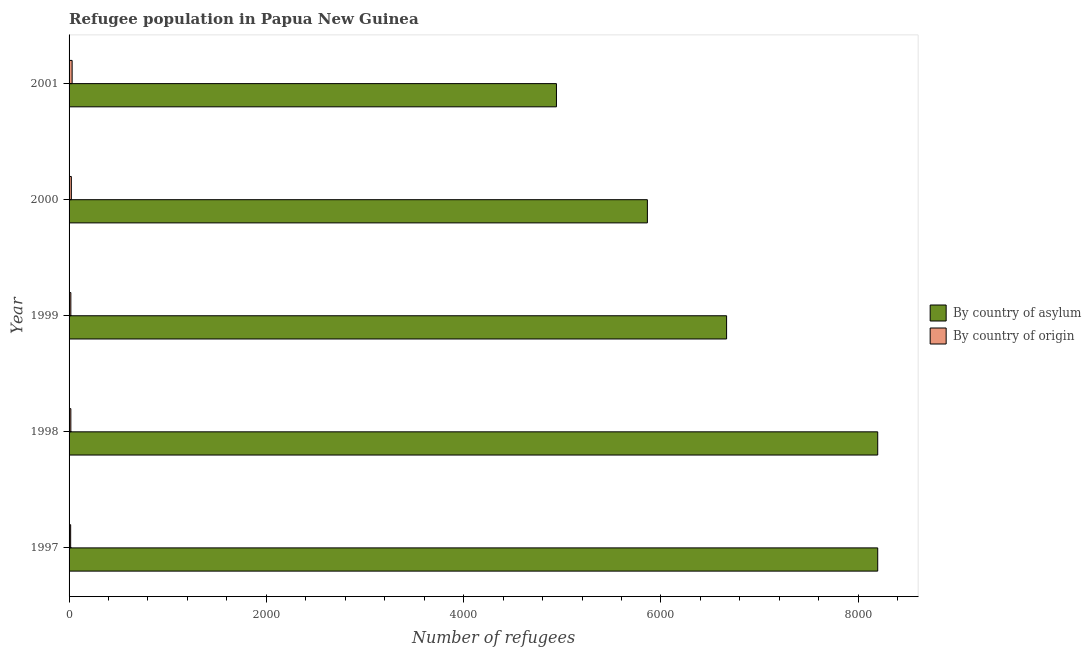How many different coloured bars are there?
Your answer should be compact. 2. How many groups of bars are there?
Your response must be concise. 5. How many bars are there on the 3rd tick from the top?
Make the answer very short. 2. How many bars are there on the 1st tick from the bottom?
Provide a succinct answer. 2. What is the label of the 4th group of bars from the top?
Your answer should be very brief. 1998. In how many cases, is the number of bars for a given year not equal to the number of legend labels?
Ensure brevity in your answer.  0. What is the number of refugees by country of origin in 1999?
Give a very brief answer. 18. Across all years, what is the maximum number of refugees by country of origin?
Ensure brevity in your answer.  31. Across all years, what is the minimum number of refugees by country of asylum?
Provide a succinct answer. 4941. What is the total number of refugees by country of origin in the graph?
Ensure brevity in your answer.  106. What is the difference between the number of refugees by country of asylum in 1997 and that in 2001?
Keep it short and to the point. 3257. What is the difference between the number of refugees by country of origin in 1998 and the number of refugees by country of asylum in 2001?
Offer a terse response. -4923. What is the average number of refugees by country of asylum per year?
Your answer should be very brief. 6773.2. In the year 2001, what is the difference between the number of refugees by country of origin and number of refugees by country of asylum?
Your response must be concise. -4910. What is the ratio of the number of refugees by country of origin in 1999 to that in 2001?
Offer a very short reply. 0.58. Is the number of refugees by country of asylum in 1999 less than that in 2000?
Offer a very short reply. No. Is the difference between the number of refugees by country of origin in 1999 and 2001 greater than the difference between the number of refugees by country of asylum in 1999 and 2001?
Your answer should be compact. No. What is the difference between the highest and the second highest number of refugees by country of asylum?
Make the answer very short. 0. What is the difference between the highest and the lowest number of refugees by country of origin?
Give a very brief answer. 15. What does the 1st bar from the top in 1998 represents?
Offer a very short reply. By country of origin. What does the 2nd bar from the bottom in 1997 represents?
Give a very brief answer. By country of origin. Are the values on the major ticks of X-axis written in scientific E-notation?
Offer a very short reply. No. Where does the legend appear in the graph?
Offer a very short reply. Center right. How are the legend labels stacked?
Provide a succinct answer. Vertical. What is the title of the graph?
Offer a very short reply. Refugee population in Papua New Guinea. What is the label or title of the X-axis?
Provide a short and direct response. Number of refugees. What is the Number of refugees of By country of asylum in 1997?
Make the answer very short. 8198. What is the Number of refugees of By country of asylum in 1998?
Provide a short and direct response. 8198. What is the Number of refugees of By country of asylum in 1999?
Offer a very short reply. 6666. What is the Number of refugees of By country of asylum in 2000?
Provide a short and direct response. 5863. What is the Number of refugees in By country of origin in 2000?
Your answer should be very brief. 23. What is the Number of refugees in By country of asylum in 2001?
Your response must be concise. 4941. Across all years, what is the maximum Number of refugees in By country of asylum?
Provide a short and direct response. 8198. Across all years, what is the minimum Number of refugees in By country of asylum?
Give a very brief answer. 4941. Across all years, what is the minimum Number of refugees of By country of origin?
Your answer should be very brief. 16. What is the total Number of refugees of By country of asylum in the graph?
Provide a succinct answer. 3.39e+04. What is the total Number of refugees of By country of origin in the graph?
Your response must be concise. 106. What is the difference between the Number of refugees of By country of origin in 1997 and that in 1998?
Keep it short and to the point. -2. What is the difference between the Number of refugees of By country of asylum in 1997 and that in 1999?
Offer a very short reply. 1532. What is the difference between the Number of refugees in By country of asylum in 1997 and that in 2000?
Provide a succinct answer. 2335. What is the difference between the Number of refugees of By country of origin in 1997 and that in 2000?
Your response must be concise. -7. What is the difference between the Number of refugees of By country of asylum in 1997 and that in 2001?
Make the answer very short. 3257. What is the difference between the Number of refugees of By country of asylum in 1998 and that in 1999?
Your answer should be very brief. 1532. What is the difference between the Number of refugees of By country of asylum in 1998 and that in 2000?
Give a very brief answer. 2335. What is the difference between the Number of refugees in By country of origin in 1998 and that in 2000?
Provide a short and direct response. -5. What is the difference between the Number of refugees of By country of asylum in 1998 and that in 2001?
Keep it short and to the point. 3257. What is the difference between the Number of refugees in By country of asylum in 1999 and that in 2000?
Your answer should be compact. 803. What is the difference between the Number of refugees of By country of origin in 1999 and that in 2000?
Provide a short and direct response. -5. What is the difference between the Number of refugees in By country of asylum in 1999 and that in 2001?
Provide a succinct answer. 1725. What is the difference between the Number of refugees of By country of origin in 1999 and that in 2001?
Ensure brevity in your answer.  -13. What is the difference between the Number of refugees of By country of asylum in 2000 and that in 2001?
Your answer should be very brief. 922. What is the difference between the Number of refugees in By country of asylum in 1997 and the Number of refugees in By country of origin in 1998?
Give a very brief answer. 8180. What is the difference between the Number of refugees in By country of asylum in 1997 and the Number of refugees in By country of origin in 1999?
Your answer should be very brief. 8180. What is the difference between the Number of refugees of By country of asylum in 1997 and the Number of refugees of By country of origin in 2000?
Offer a very short reply. 8175. What is the difference between the Number of refugees of By country of asylum in 1997 and the Number of refugees of By country of origin in 2001?
Your response must be concise. 8167. What is the difference between the Number of refugees in By country of asylum in 1998 and the Number of refugees in By country of origin in 1999?
Your answer should be compact. 8180. What is the difference between the Number of refugees of By country of asylum in 1998 and the Number of refugees of By country of origin in 2000?
Ensure brevity in your answer.  8175. What is the difference between the Number of refugees of By country of asylum in 1998 and the Number of refugees of By country of origin in 2001?
Give a very brief answer. 8167. What is the difference between the Number of refugees of By country of asylum in 1999 and the Number of refugees of By country of origin in 2000?
Keep it short and to the point. 6643. What is the difference between the Number of refugees in By country of asylum in 1999 and the Number of refugees in By country of origin in 2001?
Give a very brief answer. 6635. What is the difference between the Number of refugees in By country of asylum in 2000 and the Number of refugees in By country of origin in 2001?
Your response must be concise. 5832. What is the average Number of refugees in By country of asylum per year?
Offer a very short reply. 6773.2. What is the average Number of refugees of By country of origin per year?
Provide a short and direct response. 21.2. In the year 1997, what is the difference between the Number of refugees of By country of asylum and Number of refugees of By country of origin?
Make the answer very short. 8182. In the year 1998, what is the difference between the Number of refugees of By country of asylum and Number of refugees of By country of origin?
Keep it short and to the point. 8180. In the year 1999, what is the difference between the Number of refugees of By country of asylum and Number of refugees of By country of origin?
Ensure brevity in your answer.  6648. In the year 2000, what is the difference between the Number of refugees of By country of asylum and Number of refugees of By country of origin?
Offer a terse response. 5840. In the year 2001, what is the difference between the Number of refugees of By country of asylum and Number of refugees of By country of origin?
Give a very brief answer. 4910. What is the ratio of the Number of refugees of By country of asylum in 1997 to that in 1999?
Offer a terse response. 1.23. What is the ratio of the Number of refugees of By country of origin in 1997 to that in 1999?
Keep it short and to the point. 0.89. What is the ratio of the Number of refugees of By country of asylum in 1997 to that in 2000?
Give a very brief answer. 1.4. What is the ratio of the Number of refugees of By country of origin in 1997 to that in 2000?
Keep it short and to the point. 0.7. What is the ratio of the Number of refugees in By country of asylum in 1997 to that in 2001?
Give a very brief answer. 1.66. What is the ratio of the Number of refugees of By country of origin in 1997 to that in 2001?
Your answer should be compact. 0.52. What is the ratio of the Number of refugees in By country of asylum in 1998 to that in 1999?
Give a very brief answer. 1.23. What is the ratio of the Number of refugees in By country of asylum in 1998 to that in 2000?
Ensure brevity in your answer.  1.4. What is the ratio of the Number of refugees in By country of origin in 1998 to that in 2000?
Provide a succinct answer. 0.78. What is the ratio of the Number of refugees in By country of asylum in 1998 to that in 2001?
Offer a terse response. 1.66. What is the ratio of the Number of refugees of By country of origin in 1998 to that in 2001?
Your answer should be very brief. 0.58. What is the ratio of the Number of refugees in By country of asylum in 1999 to that in 2000?
Ensure brevity in your answer.  1.14. What is the ratio of the Number of refugees in By country of origin in 1999 to that in 2000?
Make the answer very short. 0.78. What is the ratio of the Number of refugees of By country of asylum in 1999 to that in 2001?
Give a very brief answer. 1.35. What is the ratio of the Number of refugees of By country of origin in 1999 to that in 2001?
Keep it short and to the point. 0.58. What is the ratio of the Number of refugees of By country of asylum in 2000 to that in 2001?
Your response must be concise. 1.19. What is the ratio of the Number of refugees of By country of origin in 2000 to that in 2001?
Provide a succinct answer. 0.74. What is the difference between the highest and the lowest Number of refugees of By country of asylum?
Make the answer very short. 3257. 